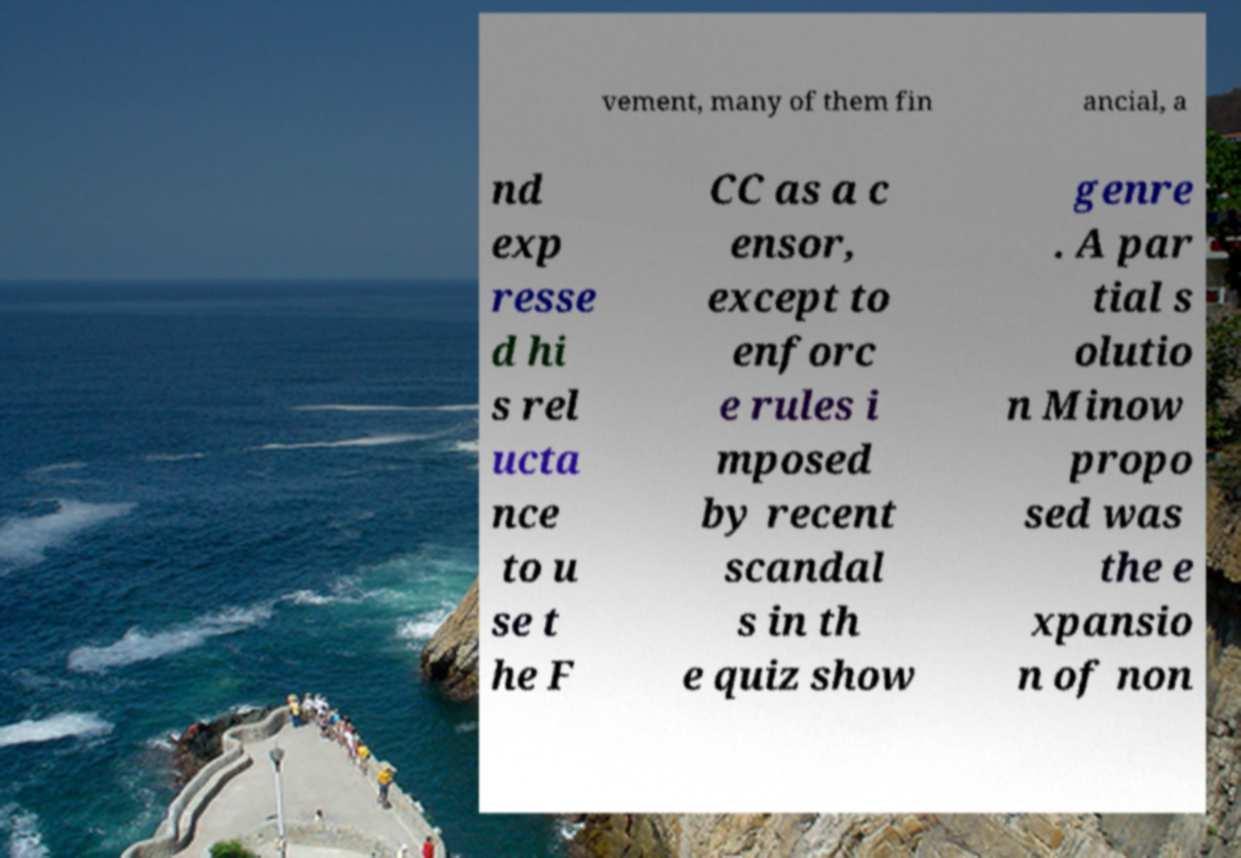What messages or text are displayed in this image? I need them in a readable, typed format. vement, many of them fin ancial, a nd exp resse d hi s rel ucta nce to u se t he F CC as a c ensor, except to enforc e rules i mposed by recent scandal s in th e quiz show genre . A par tial s olutio n Minow propo sed was the e xpansio n of non 